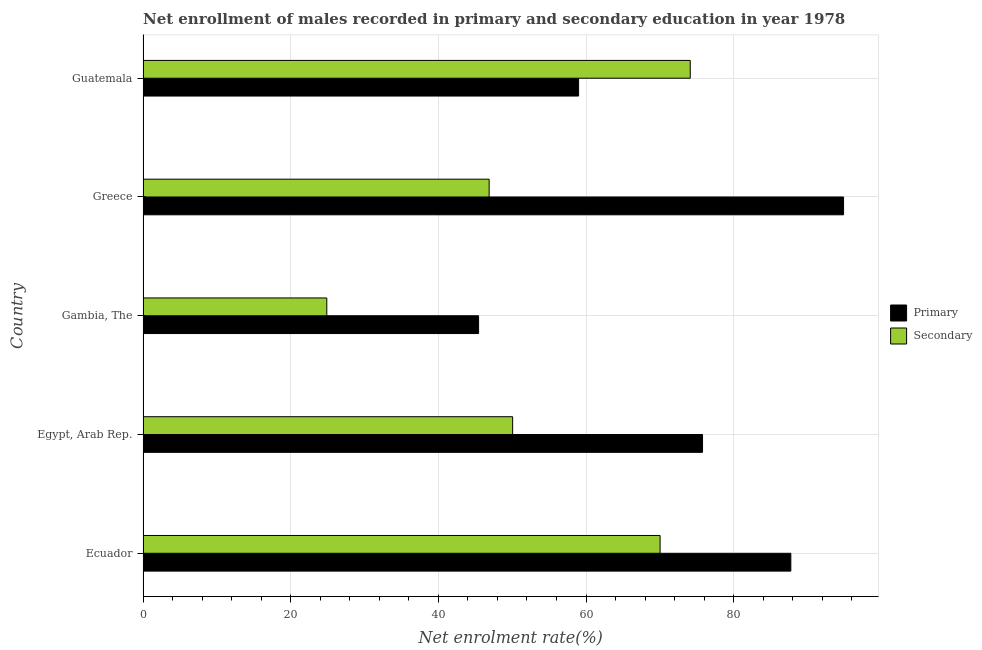Are the number of bars per tick equal to the number of legend labels?
Provide a short and direct response. Yes. How many bars are there on the 2nd tick from the top?
Offer a terse response. 2. How many bars are there on the 5th tick from the bottom?
Keep it short and to the point. 2. What is the label of the 4th group of bars from the top?
Offer a terse response. Egypt, Arab Rep. What is the enrollment rate in primary education in Guatemala?
Give a very brief answer. 58.99. Across all countries, what is the maximum enrollment rate in secondary education?
Offer a terse response. 74.12. Across all countries, what is the minimum enrollment rate in primary education?
Keep it short and to the point. 45.45. In which country was the enrollment rate in primary education maximum?
Ensure brevity in your answer.  Greece. In which country was the enrollment rate in secondary education minimum?
Give a very brief answer. Gambia, The. What is the total enrollment rate in primary education in the graph?
Your answer should be compact. 362.85. What is the difference between the enrollment rate in primary education in Egypt, Arab Rep. and that in Gambia, The?
Offer a terse response. 30.33. What is the difference between the enrollment rate in secondary education in Ecuador and the enrollment rate in primary education in Greece?
Give a very brief answer. -24.85. What is the average enrollment rate in secondary education per country?
Provide a short and direct response. 53.19. What is the difference between the enrollment rate in primary education and enrollment rate in secondary education in Guatemala?
Make the answer very short. -15.12. What is the ratio of the enrollment rate in primary education in Ecuador to that in Egypt, Arab Rep.?
Your response must be concise. 1.16. What is the difference between the highest and the second highest enrollment rate in secondary education?
Give a very brief answer. 4.09. What is the difference between the highest and the lowest enrollment rate in primary education?
Provide a succinct answer. 49.44. What does the 2nd bar from the top in Egypt, Arab Rep. represents?
Your answer should be very brief. Primary. What does the 1st bar from the bottom in Gambia, The represents?
Provide a short and direct response. Primary. Are all the bars in the graph horizontal?
Keep it short and to the point. Yes. How many countries are there in the graph?
Keep it short and to the point. 5. What is the difference between two consecutive major ticks on the X-axis?
Your response must be concise. 20. Does the graph contain any zero values?
Keep it short and to the point. No. Does the graph contain grids?
Make the answer very short. Yes. Where does the legend appear in the graph?
Ensure brevity in your answer.  Center right. What is the title of the graph?
Your answer should be very brief. Net enrollment of males recorded in primary and secondary education in year 1978. What is the label or title of the X-axis?
Your answer should be very brief. Net enrolment rate(%). What is the Net enrolment rate(%) of Primary in Ecuador?
Your answer should be compact. 87.74. What is the Net enrolment rate(%) in Secondary in Ecuador?
Ensure brevity in your answer.  70.03. What is the Net enrolment rate(%) in Primary in Egypt, Arab Rep.?
Ensure brevity in your answer.  75.78. What is the Net enrolment rate(%) in Secondary in Egypt, Arab Rep.?
Make the answer very short. 50.06. What is the Net enrolment rate(%) in Primary in Gambia, The?
Your answer should be very brief. 45.45. What is the Net enrolment rate(%) of Secondary in Gambia, The?
Ensure brevity in your answer.  24.89. What is the Net enrolment rate(%) of Primary in Greece?
Give a very brief answer. 94.88. What is the Net enrolment rate(%) in Secondary in Greece?
Provide a succinct answer. 46.88. What is the Net enrolment rate(%) of Primary in Guatemala?
Provide a short and direct response. 58.99. What is the Net enrolment rate(%) in Secondary in Guatemala?
Ensure brevity in your answer.  74.12. Across all countries, what is the maximum Net enrolment rate(%) of Primary?
Provide a short and direct response. 94.88. Across all countries, what is the maximum Net enrolment rate(%) in Secondary?
Your answer should be compact. 74.12. Across all countries, what is the minimum Net enrolment rate(%) of Primary?
Give a very brief answer. 45.45. Across all countries, what is the minimum Net enrolment rate(%) of Secondary?
Keep it short and to the point. 24.89. What is the total Net enrolment rate(%) of Primary in the graph?
Offer a very short reply. 362.85. What is the total Net enrolment rate(%) of Secondary in the graph?
Your answer should be very brief. 265.97. What is the difference between the Net enrolment rate(%) in Primary in Ecuador and that in Egypt, Arab Rep.?
Provide a short and direct response. 11.96. What is the difference between the Net enrolment rate(%) of Secondary in Ecuador and that in Egypt, Arab Rep.?
Your response must be concise. 19.97. What is the difference between the Net enrolment rate(%) in Primary in Ecuador and that in Gambia, The?
Offer a terse response. 42.29. What is the difference between the Net enrolment rate(%) of Secondary in Ecuador and that in Gambia, The?
Ensure brevity in your answer.  45.14. What is the difference between the Net enrolment rate(%) of Primary in Ecuador and that in Greece?
Ensure brevity in your answer.  -7.14. What is the difference between the Net enrolment rate(%) of Secondary in Ecuador and that in Greece?
Your response must be concise. 23.15. What is the difference between the Net enrolment rate(%) of Primary in Ecuador and that in Guatemala?
Your answer should be compact. 28.75. What is the difference between the Net enrolment rate(%) in Secondary in Ecuador and that in Guatemala?
Your answer should be compact. -4.09. What is the difference between the Net enrolment rate(%) of Primary in Egypt, Arab Rep. and that in Gambia, The?
Give a very brief answer. 30.33. What is the difference between the Net enrolment rate(%) in Secondary in Egypt, Arab Rep. and that in Gambia, The?
Your response must be concise. 25.17. What is the difference between the Net enrolment rate(%) in Primary in Egypt, Arab Rep. and that in Greece?
Offer a very short reply. -19.1. What is the difference between the Net enrolment rate(%) of Secondary in Egypt, Arab Rep. and that in Greece?
Keep it short and to the point. 3.18. What is the difference between the Net enrolment rate(%) in Primary in Egypt, Arab Rep. and that in Guatemala?
Ensure brevity in your answer.  16.79. What is the difference between the Net enrolment rate(%) in Secondary in Egypt, Arab Rep. and that in Guatemala?
Your response must be concise. -24.06. What is the difference between the Net enrolment rate(%) in Primary in Gambia, The and that in Greece?
Your answer should be compact. -49.44. What is the difference between the Net enrolment rate(%) in Secondary in Gambia, The and that in Greece?
Your response must be concise. -21.99. What is the difference between the Net enrolment rate(%) of Primary in Gambia, The and that in Guatemala?
Your answer should be compact. -13.54. What is the difference between the Net enrolment rate(%) of Secondary in Gambia, The and that in Guatemala?
Make the answer very short. -49.23. What is the difference between the Net enrolment rate(%) in Primary in Greece and that in Guatemala?
Your answer should be very brief. 35.89. What is the difference between the Net enrolment rate(%) in Secondary in Greece and that in Guatemala?
Give a very brief answer. -27.24. What is the difference between the Net enrolment rate(%) of Primary in Ecuador and the Net enrolment rate(%) of Secondary in Egypt, Arab Rep.?
Your response must be concise. 37.68. What is the difference between the Net enrolment rate(%) of Primary in Ecuador and the Net enrolment rate(%) of Secondary in Gambia, The?
Provide a short and direct response. 62.86. What is the difference between the Net enrolment rate(%) in Primary in Ecuador and the Net enrolment rate(%) in Secondary in Greece?
Make the answer very short. 40.86. What is the difference between the Net enrolment rate(%) in Primary in Ecuador and the Net enrolment rate(%) in Secondary in Guatemala?
Your response must be concise. 13.62. What is the difference between the Net enrolment rate(%) of Primary in Egypt, Arab Rep. and the Net enrolment rate(%) of Secondary in Gambia, The?
Offer a terse response. 50.9. What is the difference between the Net enrolment rate(%) in Primary in Egypt, Arab Rep. and the Net enrolment rate(%) in Secondary in Greece?
Provide a succinct answer. 28.9. What is the difference between the Net enrolment rate(%) in Primary in Egypt, Arab Rep. and the Net enrolment rate(%) in Secondary in Guatemala?
Give a very brief answer. 1.66. What is the difference between the Net enrolment rate(%) of Primary in Gambia, The and the Net enrolment rate(%) of Secondary in Greece?
Give a very brief answer. -1.43. What is the difference between the Net enrolment rate(%) of Primary in Gambia, The and the Net enrolment rate(%) of Secondary in Guatemala?
Provide a succinct answer. -28.67. What is the difference between the Net enrolment rate(%) in Primary in Greece and the Net enrolment rate(%) in Secondary in Guatemala?
Keep it short and to the point. 20.77. What is the average Net enrolment rate(%) in Primary per country?
Offer a terse response. 72.57. What is the average Net enrolment rate(%) in Secondary per country?
Your answer should be compact. 53.19. What is the difference between the Net enrolment rate(%) of Primary and Net enrolment rate(%) of Secondary in Ecuador?
Offer a very short reply. 17.71. What is the difference between the Net enrolment rate(%) in Primary and Net enrolment rate(%) in Secondary in Egypt, Arab Rep.?
Offer a very short reply. 25.72. What is the difference between the Net enrolment rate(%) of Primary and Net enrolment rate(%) of Secondary in Gambia, The?
Ensure brevity in your answer.  20.56. What is the difference between the Net enrolment rate(%) of Primary and Net enrolment rate(%) of Secondary in Greece?
Offer a terse response. 48.01. What is the difference between the Net enrolment rate(%) in Primary and Net enrolment rate(%) in Secondary in Guatemala?
Provide a short and direct response. -15.12. What is the ratio of the Net enrolment rate(%) of Primary in Ecuador to that in Egypt, Arab Rep.?
Your answer should be very brief. 1.16. What is the ratio of the Net enrolment rate(%) of Secondary in Ecuador to that in Egypt, Arab Rep.?
Give a very brief answer. 1.4. What is the ratio of the Net enrolment rate(%) in Primary in Ecuador to that in Gambia, The?
Give a very brief answer. 1.93. What is the ratio of the Net enrolment rate(%) of Secondary in Ecuador to that in Gambia, The?
Give a very brief answer. 2.81. What is the ratio of the Net enrolment rate(%) of Primary in Ecuador to that in Greece?
Give a very brief answer. 0.92. What is the ratio of the Net enrolment rate(%) of Secondary in Ecuador to that in Greece?
Provide a succinct answer. 1.49. What is the ratio of the Net enrolment rate(%) of Primary in Ecuador to that in Guatemala?
Offer a terse response. 1.49. What is the ratio of the Net enrolment rate(%) of Secondary in Ecuador to that in Guatemala?
Offer a terse response. 0.94. What is the ratio of the Net enrolment rate(%) of Primary in Egypt, Arab Rep. to that in Gambia, The?
Provide a short and direct response. 1.67. What is the ratio of the Net enrolment rate(%) of Secondary in Egypt, Arab Rep. to that in Gambia, The?
Offer a very short reply. 2.01. What is the ratio of the Net enrolment rate(%) of Primary in Egypt, Arab Rep. to that in Greece?
Make the answer very short. 0.8. What is the ratio of the Net enrolment rate(%) of Secondary in Egypt, Arab Rep. to that in Greece?
Provide a short and direct response. 1.07. What is the ratio of the Net enrolment rate(%) of Primary in Egypt, Arab Rep. to that in Guatemala?
Offer a terse response. 1.28. What is the ratio of the Net enrolment rate(%) in Secondary in Egypt, Arab Rep. to that in Guatemala?
Keep it short and to the point. 0.68. What is the ratio of the Net enrolment rate(%) of Primary in Gambia, The to that in Greece?
Ensure brevity in your answer.  0.48. What is the ratio of the Net enrolment rate(%) of Secondary in Gambia, The to that in Greece?
Offer a very short reply. 0.53. What is the ratio of the Net enrolment rate(%) in Primary in Gambia, The to that in Guatemala?
Provide a short and direct response. 0.77. What is the ratio of the Net enrolment rate(%) in Secondary in Gambia, The to that in Guatemala?
Your response must be concise. 0.34. What is the ratio of the Net enrolment rate(%) of Primary in Greece to that in Guatemala?
Provide a succinct answer. 1.61. What is the ratio of the Net enrolment rate(%) of Secondary in Greece to that in Guatemala?
Offer a terse response. 0.63. What is the difference between the highest and the second highest Net enrolment rate(%) of Primary?
Offer a terse response. 7.14. What is the difference between the highest and the second highest Net enrolment rate(%) in Secondary?
Offer a terse response. 4.09. What is the difference between the highest and the lowest Net enrolment rate(%) of Primary?
Offer a terse response. 49.44. What is the difference between the highest and the lowest Net enrolment rate(%) of Secondary?
Keep it short and to the point. 49.23. 